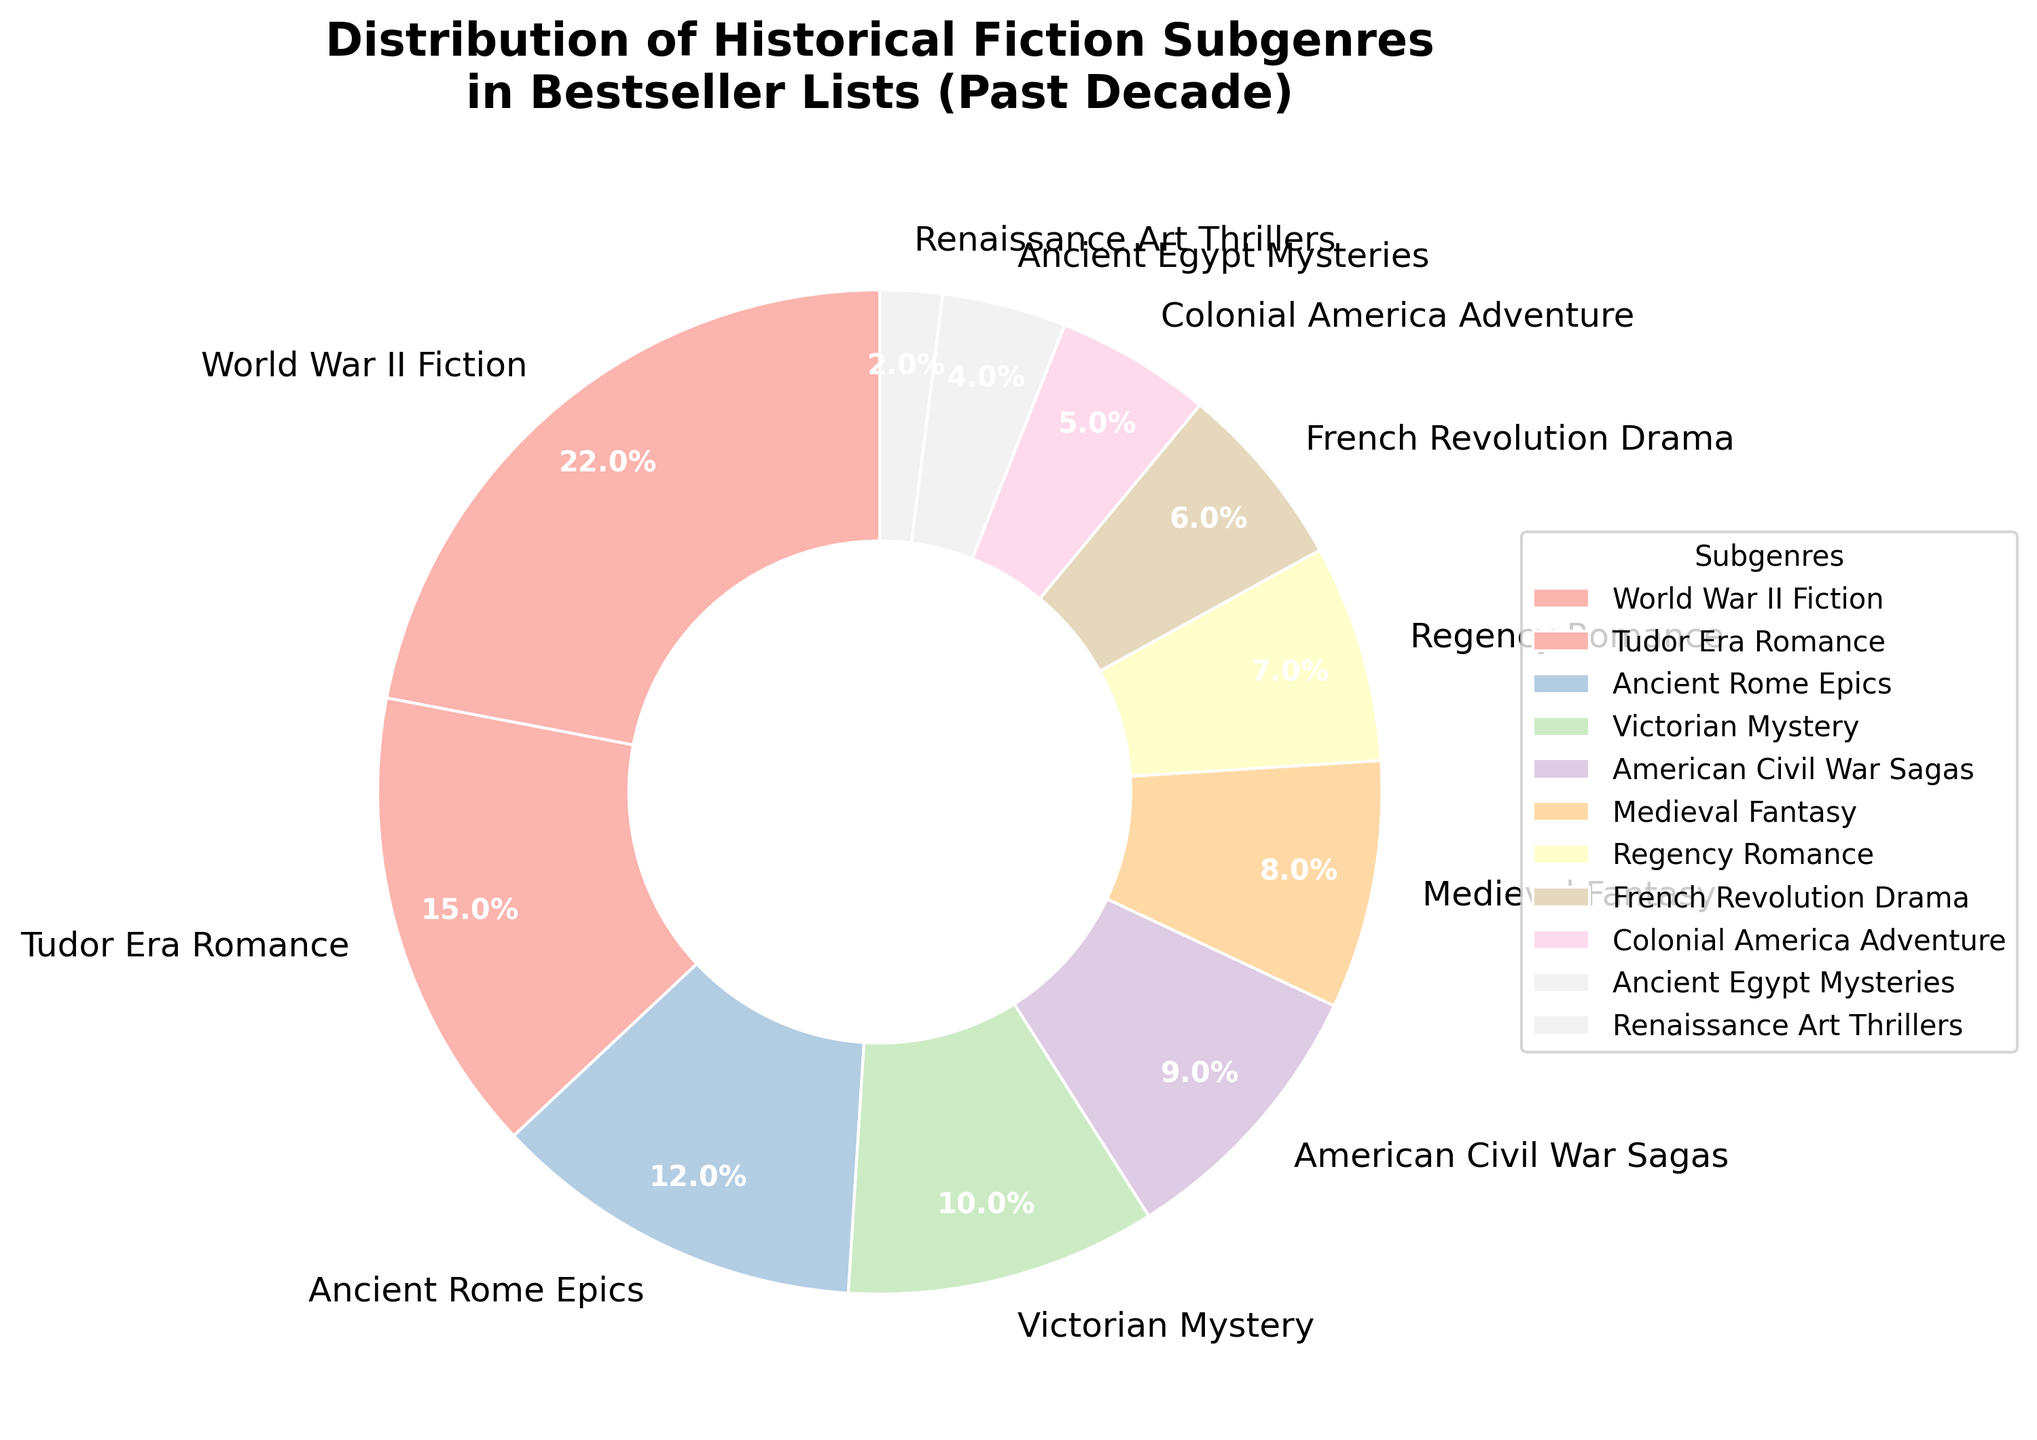Which subgenre has the largest share in the bestseller list over the past decade? The figure shows that the subgenre with the largest section of the pie chart is "World War II Fiction".
Answer: World War II Fiction How much larger is the percentage of World War II Fiction compared to Tudor Era Romance? The figure shows that World War II Fiction is 22% while Tudor Era Romance is 15%. The difference is 22 - 15 = 7%.
Answer: 7% What is the combined percentage of American Civil War Sagas and Medieval Fantasy? The figure indicates American Civil War Sagas at 9% and Medieval Fantasy at 8%. Combined, this is 9 + 8 = 17%.
Answer: 17% Which subgenre has the smallest representation in the pie chart? The figure shows that the smallest section of the pie chart is "Renaissance Art Thrillers" with 2%.
Answer: Renaissance Art Thrillers How does the percentage of Ancient Rome Epics compare to Victorian Mystery? The figure indicates that Ancient Rome Epics is 12% while Victorian Mystery is 10%. Ancient Rome Epics has a larger percentage.
Answer: Ancient Rome Epics What is the difference in percentage between Tudor Era Romance and Ancient Rome Epics? The figure shows Tudor Era Romance is 15% and Ancient Rome Epics is 12%. The difference is 15 - 12 = 3%.
Answer: 3% Which subgenre is closest in percentage to Colonial America Adventure? According to the figure, Colonial America Adventure is 5%. The subgenre closest in percentage is Ancient Egypt Mysteries at 4%.
Answer: Ancient Egypt Mysteries What is the total percentage of all subgenres with less than 10% representation? The subgenres with less than 10% are American Civil War Sagas (9%), Medieval Fantasy (8%), Regency Romance (7%), French Revolution Drama (6%), Colonial America Adventure (5%), Ancient Egypt Mysteries (4%), and Renaissance Art Thrillers (2%). Summing these: 9 + 8 + 7 + 6 + 5 + 4 + 2 = 41%.
Answer: 41% Identify the subgenres that individually form more than 10% of the chart. The figure shows that the subgenres with more than 10% are World War II Fiction (22%), Tudor Era Romance (15%), and Ancient Rome Epics (12%).
Answer: World War II Fiction, Tudor Era Romance, Ancient Rome Epics 